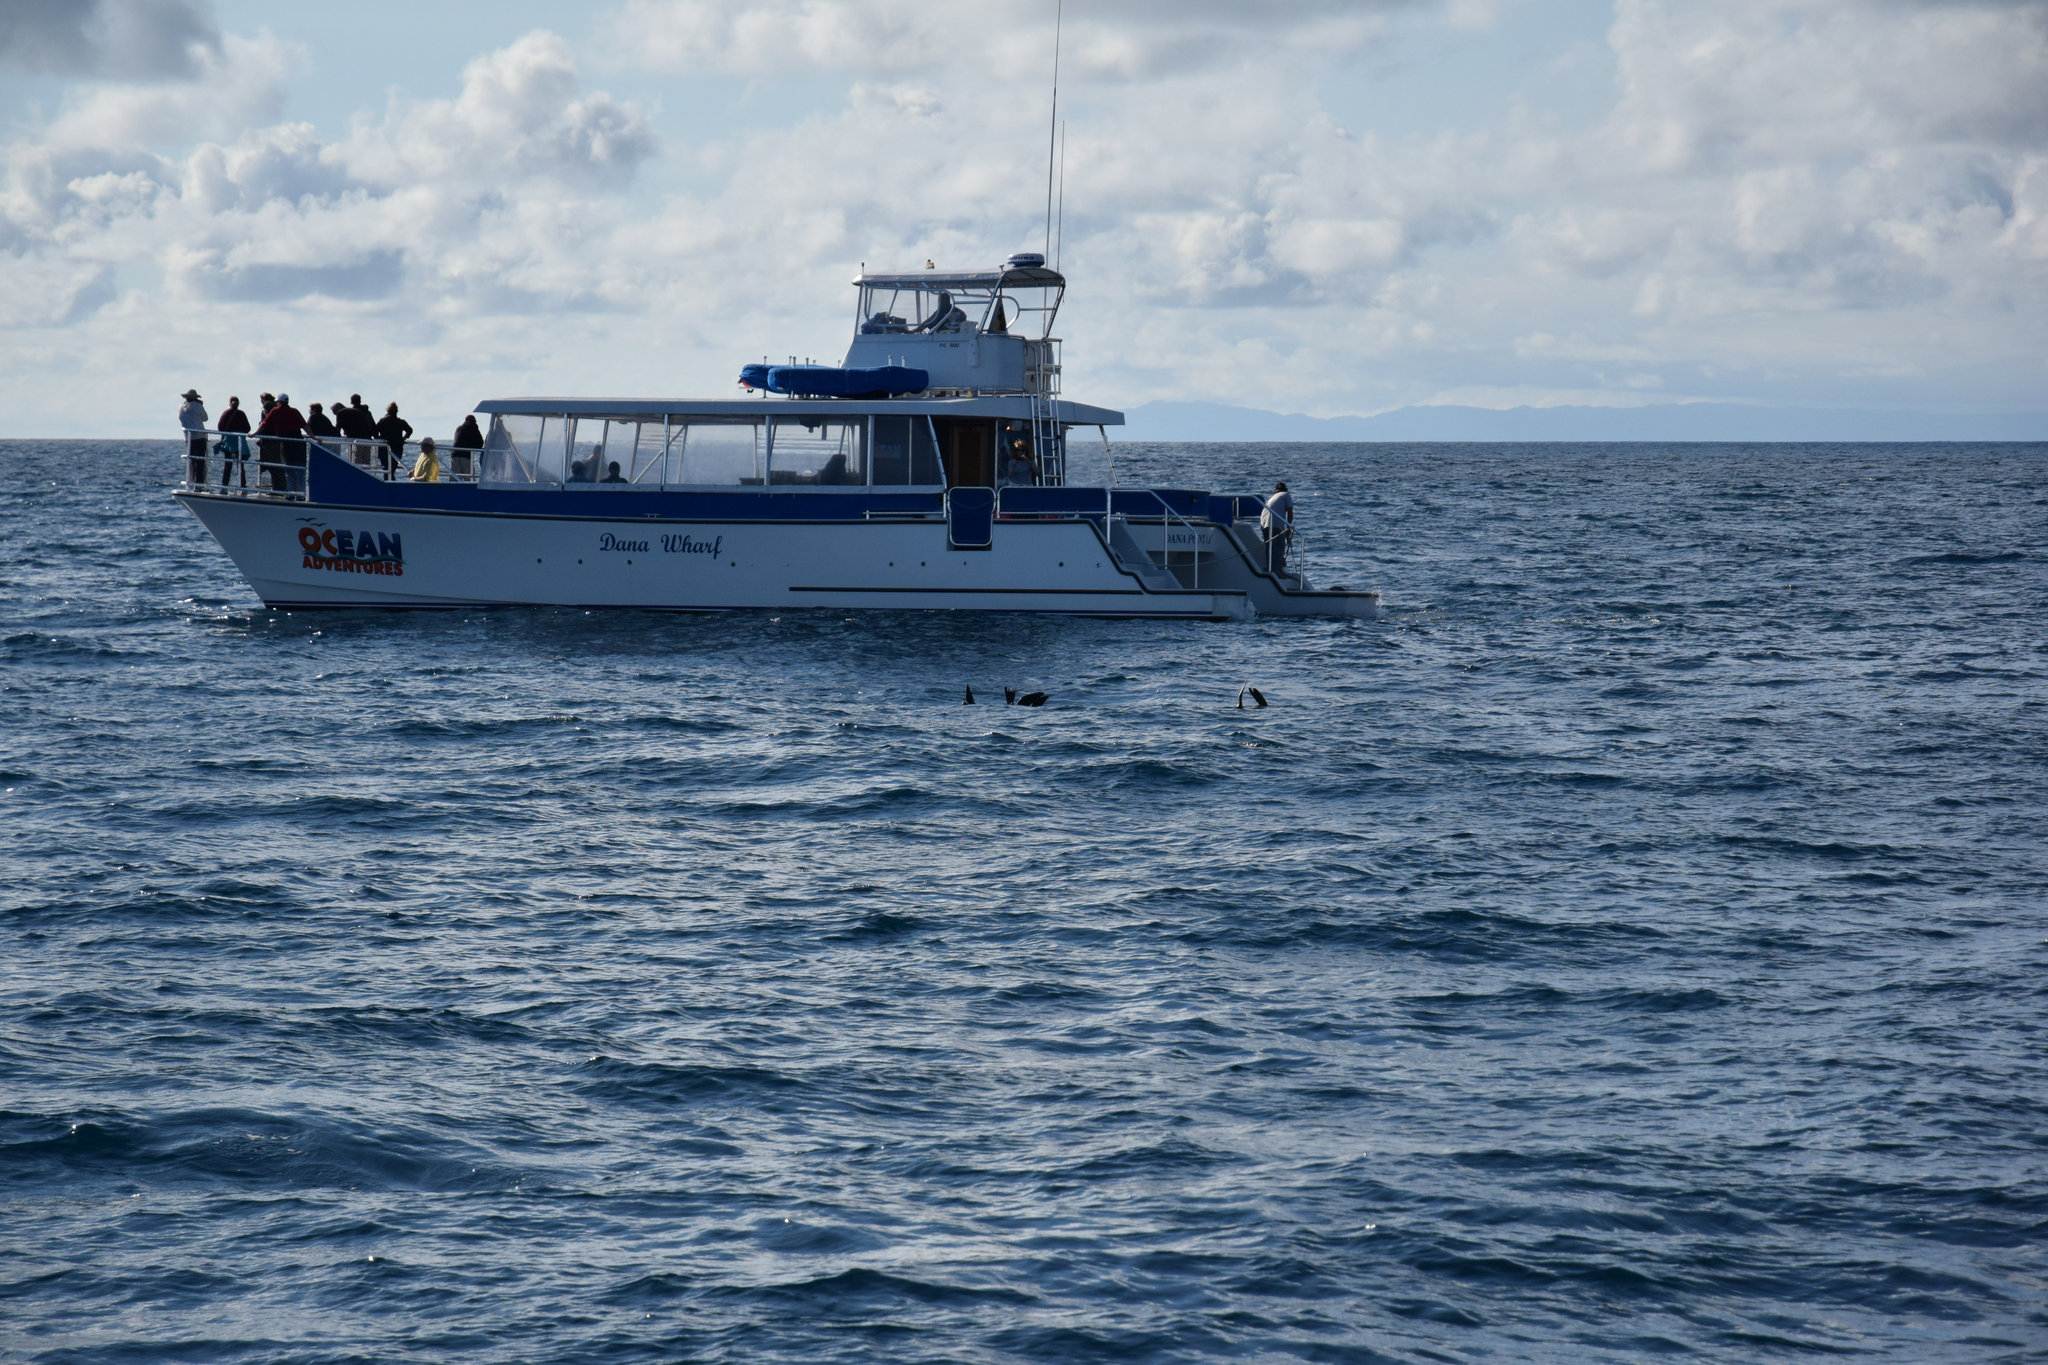In one or two sentences, can you explain what this image depicts? In this aimeg, we can see few people are sailing a boat on the water. Background we can see the cloudy sky. 